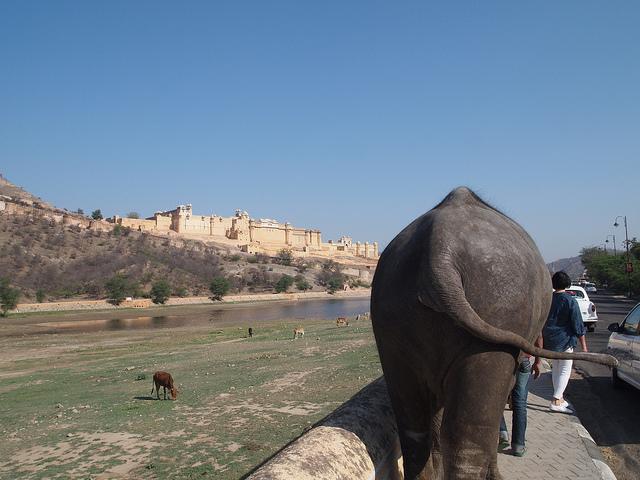Is the elephant on pavement?
Write a very short answer. Yes. Can you see the elephant's trunk?
Give a very brief answer. No. What is the cage made out of?
Keep it brief. Concrete. Is this picture in the northern hemisphere?
Answer briefly. No. Is the elephants walking straight down the road?
Answer briefly. Yes. What is grazing?
Short answer required. Cow. 